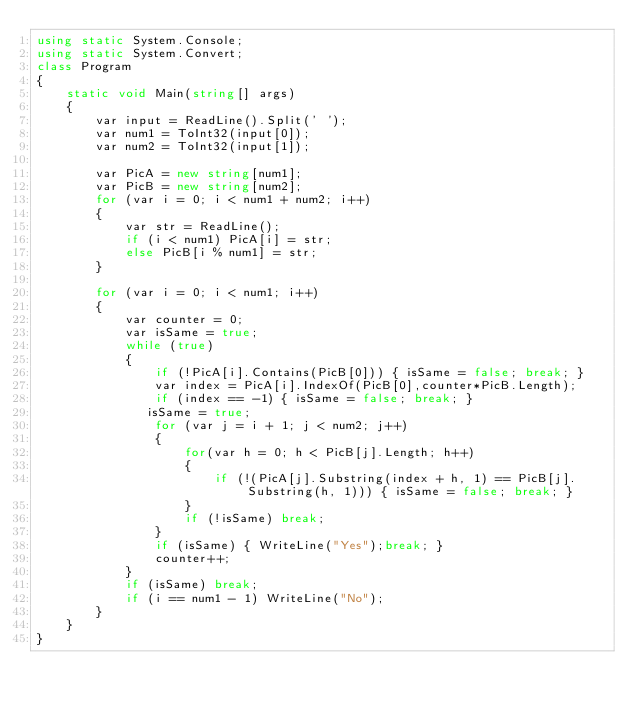Convert code to text. <code><loc_0><loc_0><loc_500><loc_500><_C#_>using static System.Console;
using static System.Convert;
class Program
{
    static void Main(string[] args)
    {
        var input = ReadLine().Split(' ');
        var num1 = ToInt32(input[0]);
        var num2 = ToInt32(input[1]);

        var PicA = new string[num1];
        var PicB = new string[num2];
        for (var i = 0; i < num1 + num2; i++)
        {
            var str = ReadLine();
            if (i < num1) PicA[i] = str;
            else PicB[i % num1] = str;
        }

        for (var i = 0; i < num1; i++)
        {
            var counter = 0;
            var isSame = true;
            while (true)
            {
                if (!PicA[i].Contains(PicB[0])) { isSame = false; break; }
                var index = PicA[i].IndexOf(PicB[0],counter*PicB.Length);
                if (index == -1) { isSame = false; break; }
               isSame = true;
                for (var j = i + 1; j < num2; j++)
                {
                    for(var h = 0; h < PicB[j].Length; h++)
                    {
                        if (!(PicA[j].Substring(index + h, 1) == PicB[j].Substring(h, 1))) { isSame = false; break; }
                    }
                    if (!isSame) break;
                }
                if (isSame) { WriteLine("Yes");break; }
                counter++;
            }
            if (isSame) break;
            if (i == num1 - 1) WriteLine("No");
        }
    }
}

</code> 